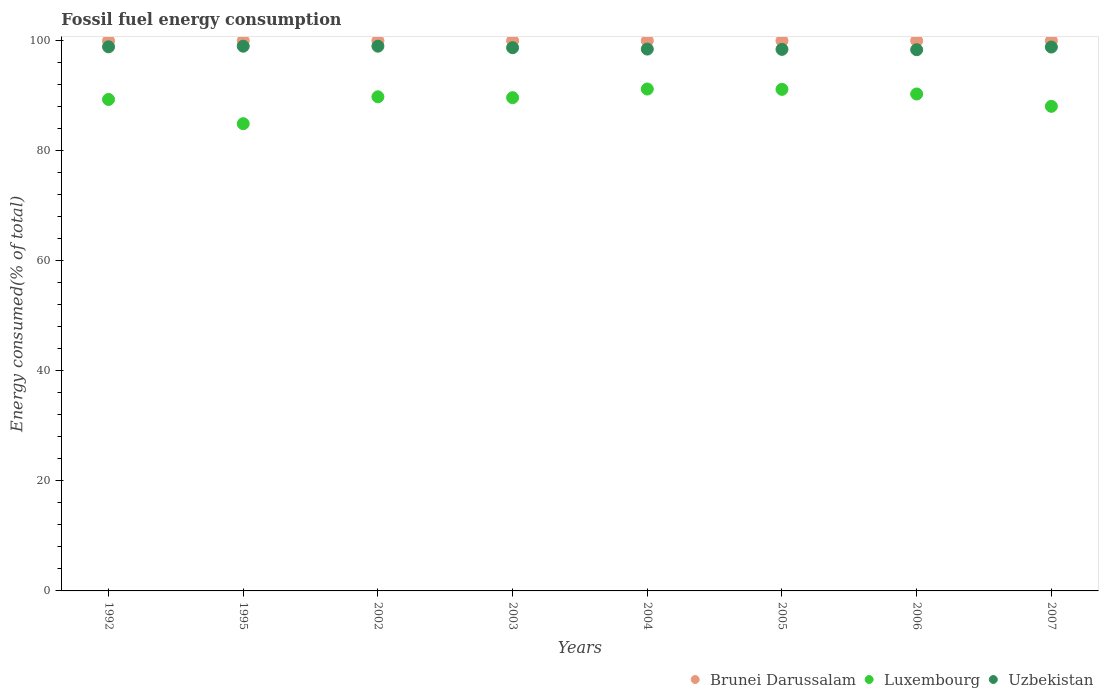What is the percentage of energy consumed in Uzbekistan in 2005?
Offer a very short reply. 98.43. Across all years, what is the maximum percentage of energy consumed in Brunei Darussalam?
Your answer should be very brief. 100. Across all years, what is the minimum percentage of energy consumed in Brunei Darussalam?
Your response must be concise. 99.96. In which year was the percentage of energy consumed in Luxembourg maximum?
Make the answer very short. 2004. In which year was the percentage of energy consumed in Brunei Darussalam minimum?
Provide a short and direct response. 1992. What is the total percentage of energy consumed in Luxembourg in the graph?
Make the answer very short. 714.48. What is the difference between the percentage of energy consumed in Luxembourg in 2005 and that in 2006?
Offer a very short reply. 0.84. What is the difference between the percentage of energy consumed in Brunei Darussalam in 2006 and the percentage of energy consumed in Luxembourg in 2002?
Offer a very short reply. 10.19. What is the average percentage of energy consumed in Brunei Darussalam per year?
Your answer should be very brief. 100. In the year 1995, what is the difference between the percentage of energy consumed in Uzbekistan and percentage of energy consumed in Brunei Darussalam?
Make the answer very short. -1. Is the difference between the percentage of energy consumed in Uzbekistan in 2005 and 2007 greater than the difference between the percentage of energy consumed in Brunei Darussalam in 2005 and 2007?
Offer a very short reply. No. What is the difference between the highest and the second highest percentage of energy consumed in Brunei Darussalam?
Your answer should be very brief. 0. What is the difference between the highest and the lowest percentage of energy consumed in Uzbekistan?
Your answer should be compact. 0.64. Is the sum of the percentage of energy consumed in Brunei Darussalam in 1992 and 2006 greater than the maximum percentage of energy consumed in Luxembourg across all years?
Your answer should be very brief. Yes. Does the percentage of energy consumed in Brunei Darussalam monotonically increase over the years?
Your response must be concise. No. Is the percentage of energy consumed in Brunei Darussalam strictly less than the percentage of energy consumed in Uzbekistan over the years?
Offer a very short reply. No. What is the difference between two consecutive major ticks on the Y-axis?
Your response must be concise. 20. Are the values on the major ticks of Y-axis written in scientific E-notation?
Ensure brevity in your answer.  No. Does the graph contain any zero values?
Provide a short and direct response. No. Where does the legend appear in the graph?
Offer a terse response. Bottom right. What is the title of the graph?
Offer a terse response. Fossil fuel energy consumption. What is the label or title of the Y-axis?
Keep it short and to the point. Energy consumed(% of total). What is the Energy consumed(% of total) of Brunei Darussalam in 1992?
Give a very brief answer. 99.96. What is the Energy consumed(% of total) in Luxembourg in 1992?
Your answer should be very brief. 89.33. What is the Energy consumed(% of total) of Uzbekistan in 1992?
Offer a very short reply. 98.89. What is the Energy consumed(% of total) of Brunei Darussalam in 1995?
Offer a terse response. 100. What is the Energy consumed(% of total) of Luxembourg in 1995?
Ensure brevity in your answer.  84.92. What is the Energy consumed(% of total) of Uzbekistan in 1995?
Provide a short and direct response. 99. What is the Energy consumed(% of total) in Brunei Darussalam in 2002?
Make the answer very short. 100. What is the Energy consumed(% of total) in Luxembourg in 2002?
Make the answer very short. 89.81. What is the Energy consumed(% of total) in Uzbekistan in 2002?
Your response must be concise. 99.01. What is the Energy consumed(% of total) of Brunei Darussalam in 2003?
Your response must be concise. 100. What is the Energy consumed(% of total) in Luxembourg in 2003?
Provide a short and direct response. 89.65. What is the Energy consumed(% of total) of Uzbekistan in 2003?
Ensure brevity in your answer.  98.73. What is the Energy consumed(% of total) of Brunei Darussalam in 2004?
Your answer should be very brief. 100. What is the Energy consumed(% of total) of Luxembourg in 2004?
Provide a short and direct response. 91.22. What is the Energy consumed(% of total) in Uzbekistan in 2004?
Provide a short and direct response. 98.48. What is the Energy consumed(% of total) in Brunei Darussalam in 2005?
Keep it short and to the point. 100. What is the Energy consumed(% of total) in Luxembourg in 2005?
Make the answer very short. 91.16. What is the Energy consumed(% of total) of Uzbekistan in 2005?
Offer a very short reply. 98.43. What is the Energy consumed(% of total) in Luxembourg in 2006?
Keep it short and to the point. 90.32. What is the Energy consumed(% of total) of Uzbekistan in 2006?
Ensure brevity in your answer.  98.37. What is the Energy consumed(% of total) in Brunei Darussalam in 2007?
Provide a short and direct response. 100. What is the Energy consumed(% of total) in Luxembourg in 2007?
Provide a succinct answer. 88.07. What is the Energy consumed(% of total) of Uzbekistan in 2007?
Give a very brief answer. 98.85. Across all years, what is the maximum Energy consumed(% of total) in Luxembourg?
Your answer should be compact. 91.22. Across all years, what is the maximum Energy consumed(% of total) of Uzbekistan?
Your response must be concise. 99.01. Across all years, what is the minimum Energy consumed(% of total) in Brunei Darussalam?
Your answer should be very brief. 99.96. Across all years, what is the minimum Energy consumed(% of total) of Luxembourg?
Keep it short and to the point. 84.92. Across all years, what is the minimum Energy consumed(% of total) in Uzbekistan?
Your answer should be compact. 98.37. What is the total Energy consumed(% of total) of Brunei Darussalam in the graph?
Provide a succinct answer. 799.96. What is the total Energy consumed(% of total) of Luxembourg in the graph?
Offer a very short reply. 714.48. What is the total Energy consumed(% of total) of Uzbekistan in the graph?
Your response must be concise. 789.76. What is the difference between the Energy consumed(% of total) in Brunei Darussalam in 1992 and that in 1995?
Provide a short and direct response. -0.04. What is the difference between the Energy consumed(% of total) in Luxembourg in 1992 and that in 1995?
Provide a succinct answer. 4.41. What is the difference between the Energy consumed(% of total) of Uzbekistan in 1992 and that in 1995?
Provide a succinct answer. -0.11. What is the difference between the Energy consumed(% of total) of Brunei Darussalam in 1992 and that in 2002?
Give a very brief answer. -0.04. What is the difference between the Energy consumed(% of total) in Luxembourg in 1992 and that in 2002?
Provide a short and direct response. -0.48. What is the difference between the Energy consumed(% of total) of Uzbekistan in 1992 and that in 2002?
Give a very brief answer. -0.11. What is the difference between the Energy consumed(% of total) in Brunei Darussalam in 1992 and that in 2003?
Give a very brief answer. -0.04. What is the difference between the Energy consumed(% of total) in Luxembourg in 1992 and that in 2003?
Provide a succinct answer. -0.33. What is the difference between the Energy consumed(% of total) of Uzbekistan in 1992 and that in 2003?
Offer a very short reply. 0.16. What is the difference between the Energy consumed(% of total) of Brunei Darussalam in 1992 and that in 2004?
Your answer should be compact. -0.04. What is the difference between the Energy consumed(% of total) of Luxembourg in 1992 and that in 2004?
Offer a terse response. -1.89. What is the difference between the Energy consumed(% of total) of Uzbekistan in 1992 and that in 2004?
Provide a succinct answer. 0.41. What is the difference between the Energy consumed(% of total) of Brunei Darussalam in 1992 and that in 2005?
Keep it short and to the point. -0.04. What is the difference between the Energy consumed(% of total) in Luxembourg in 1992 and that in 2005?
Make the answer very short. -1.83. What is the difference between the Energy consumed(% of total) of Uzbekistan in 1992 and that in 2005?
Give a very brief answer. 0.46. What is the difference between the Energy consumed(% of total) in Brunei Darussalam in 1992 and that in 2006?
Offer a very short reply. -0.04. What is the difference between the Energy consumed(% of total) of Luxembourg in 1992 and that in 2006?
Make the answer very short. -0.99. What is the difference between the Energy consumed(% of total) of Uzbekistan in 1992 and that in 2006?
Your answer should be compact. 0.53. What is the difference between the Energy consumed(% of total) of Brunei Darussalam in 1992 and that in 2007?
Your answer should be very brief. -0.04. What is the difference between the Energy consumed(% of total) of Luxembourg in 1992 and that in 2007?
Provide a succinct answer. 1.25. What is the difference between the Energy consumed(% of total) in Uzbekistan in 1992 and that in 2007?
Offer a terse response. 0.04. What is the difference between the Energy consumed(% of total) in Luxembourg in 1995 and that in 2002?
Provide a short and direct response. -4.89. What is the difference between the Energy consumed(% of total) in Uzbekistan in 1995 and that in 2002?
Make the answer very short. -0. What is the difference between the Energy consumed(% of total) of Luxembourg in 1995 and that in 2003?
Give a very brief answer. -4.73. What is the difference between the Energy consumed(% of total) of Uzbekistan in 1995 and that in 2003?
Your response must be concise. 0.27. What is the difference between the Energy consumed(% of total) of Brunei Darussalam in 1995 and that in 2004?
Give a very brief answer. 0. What is the difference between the Energy consumed(% of total) in Luxembourg in 1995 and that in 2004?
Your response must be concise. -6.3. What is the difference between the Energy consumed(% of total) of Uzbekistan in 1995 and that in 2004?
Ensure brevity in your answer.  0.52. What is the difference between the Energy consumed(% of total) in Brunei Darussalam in 1995 and that in 2005?
Provide a succinct answer. 0. What is the difference between the Energy consumed(% of total) in Luxembourg in 1995 and that in 2005?
Keep it short and to the point. -6.24. What is the difference between the Energy consumed(% of total) of Uzbekistan in 1995 and that in 2005?
Make the answer very short. 0.58. What is the difference between the Energy consumed(% of total) of Brunei Darussalam in 1995 and that in 2006?
Offer a terse response. 0. What is the difference between the Energy consumed(% of total) of Luxembourg in 1995 and that in 2006?
Offer a terse response. -5.4. What is the difference between the Energy consumed(% of total) in Uzbekistan in 1995 and that in 2006?
Ensure brevity in your answer.  0.64. What is the difference between the Energy consumed(% of total) in Luxembourg in 1995 and that in 2007?
Your answer should be compact. -3.15. What is the difference between the Energy consumed(% of total) of Uzbekistan in 1995 and that in 2007?
Give a very brief answer. 0.15. What is the difference between the Energy consumed(% of total) in Brunei Darussalam in 2002 and that in 2003?
Ensure brevity in your answer.  -0. What is the difference between the Energy consumed(% of total) in Luxembourg in 2002 and that in 2003?
Offer a terse response. 0.15. What is the difference between the Energy consumed(% of total) of Uzbekistan in 2002 and that in 2003?
Your response must be concise. 0.27. What is the difference between the Energy consumed(% of total) of Brunei Darussalam in 2002 and that in 2004?
Offer a very short reply. -0. What is the difference between the Energy consumed(% of total) in Luxembourg in 2002 and that in 2004?
Your answer should be very brief. -1.41. What is the difference between the Energy consumed(% of total) in Uzbekistan in 2002 and that in 2004?
Make the answer very short. 0.53. What is the difference between the Energy consumed(% of total) in Brunei Darussalam in 2002 and that in 2005?
Your answer should be compact. -0. What is the difference between the Energy consumed(% of total) in Luxembourg in 2002 and that in 2005?
Offer a terse response. -1.35. What is the difference between the Energy consumed(% of total) in Uzbekistan in 2002 and that in 2005?
Your response must be concise. 0.58. What is the difference between the Energy consumed(% of total) in Brunei Darussalam in 2002 and that in 2006?
Your response must be concise. -0. What is the difference between the Energy consumed(% of total) in Luxembourg in 2002 and that in 2006?
Your response must be concise. -0.51. What is the difference between the Energy consumed(% of total) in Uzbekistan in 2002 and that in 2006?
Give a very brief answer. 0.64. What is the difference between the Energy consumed(% of total) in Brunei Darussalam in 2002 and that in 2007?
Your response must be concise. -0. What is the difference between the Energy consumed(% of total) in Luxembourg in 2002 and that in 2007?
Your response must be concise. 1.73. What is the difference between the Energy consumed(% of total) of Uzbekistan in 2002 and that in 2007?
Keep it short and to the point. 0.15. What is the difference between the Energy consumed(% of total) of Brunei Darussalam in 2003 and that in 2004?
Offer a terse response. 0. What is the difference between the Energy consumed(% of total) in Luxembourg in 2003 and that in 2004?
Your answer should be very brief. -1.57. What is the difference between the Energy consumed(% of total) of Uzbekistan in 2003 and that in 2004?
Your response must be concise. 0.25. What is the difference between the Energy consumed(% of total) in Luxembourg in 2003 and that in 2005?
Keep it short and to the point. -1.51. What is the difference between the Energy consumed(% of total) of Uzbekistan in 2003 and that in 2005?
Ensure brevity in your answer.  0.31. What is the difference between the Energy consumed(% of total) of Luxembourg in 2003 and that in 2006?
Your answer should be very brief. -0.67. What is the difference between the Energy consumed(% of total) in Uzbekistan in 2003 and that in 2006?
Offer a terse response. 0.37. What is the difference between the Energy consumed(% of total) of Brunei Darussalam in 2003 and that in 2007?
Keep it short and to the point. 0. What is the difference between the Energy consumed(% of total) in Luxembourg in 2003 and that in 2007?
Ensure brevity in your answer.  1.58. What is the difference between the Energy consumed(% of total) in Uzbekistan in 2003 and that in 2007?
Give a very brief answer. -0.12. What is the difference between the Energy consumed(% of total) in Luxembourg in 2004 and that in 2005?
Your answer should be very brief. 0.06. What is the difference between the Energy consumed(% of total) of Uzbekistan in 2004 and that in 2005?
Give a very brief answer. 0.05. What is the difference between the Energy consumed(% of total) of Brunei Darussalam in 2004 and that in 2006?
Provide a succinct answer. 0. What is the difference between the Energy consumed(% of total) of Luxembourg in 2004 and that in 2006?
Offer a terse response. 0.9. What is the difference between the Energy consumed(% of total) in Uzbekistan in 2004 and that in 2006?
Provide a succinct answer. 0.11. What is the difference between the Energy consumed(% of total) of Luxembourg in 2004 and that in 2007?
Provide a short and direct response. 3.15. What is the difference between the Energy consumed(% of total) of Uzbekistan in 2004 and that in 2007?
Give a very brief answer. -0.37. What is the difference between the Energy consumed(% of total) of Luxembourg in 2005 and that in 2006?
Offer a terse response. 0.84. What is the difference between the Energy consumed(% of total) of Uzbekistan in 2005 and that in 2006?
Keep it short and to the point. 0.06. What is the difference between the Energy consumed(% of total) of Luxembourg in 2005 and that in 2007?
Your response must be concise. 3.09. What is the difference between the Energy consumed(% of total) in Uzbekistan in 2005 and that in 2007?
Your answer should be compact. -0.42. What is the difference between the Energy consumed(% of total) of Luxembourg in 2006 and that in 2007?
Your answer should be very brief. 2.25. What is the difference between the Energy consumed(% of total) in Uzbekistan in 2006 and that in 2007?
Your answer should be very brief. -0.49. What is the difference between the Energy consumed(% of total) in Brunei Darussalam in 1992 and the Energy consumed(% of total) in Luxembourg in 1995?
Give a very brief answer. 15.04. What is the difference between the Energy consumed(% of total) of Brunei Darussalam in 1992 and the Energy consumed(% of total) of Uzbekistan in 1995?
Offer a very short reply. 0.96. What is the difference between the Energy consumed(% of total) of Luxembourg in 1992 and the Energy consumed(% of total) of Uzbekistan in 1995?
Ensure brevity in your answer.  -9.68. What is the difference between the Energy consumed(% of total) in Brunei Darussalam in 1992 and the Energy consumed(% of total) in Luxembourg in 2002?
Provide a succinct answer. 10.15. What is the difference between the Energy consumed(% of total) in Brunei Darussalam in 1992 and the Energy consumed(% of total) in Uzbekistan in 2002?
Make the answer very short. 0.96. What is the difference between the Energy consumed(% of total) in Luxembourg in 1992 and the Energy consumed(% of total) in Uzbekistan in 2002?
Make the answer very short. -9.68. What is the difference between the Energy consumed(% of total) in Brunei Darussalam in 1992 and the Energy consumed(% of total) in Luxembourg in 2003?
Provide a succinct answer. 10.31. What is the difference between the Energy consumed(% of total) of Brunei Darussalam in 1992 and the Energy consumed(% of total) of Uzbekistan in 2003?
Offer a terse response. 1.23. What is the difference between the Energy consumed(% of total) in Luxembourg in 1992 and the Energy consumed(% of total) in Uzbekistan in 2003?
Offer a very short reply. -9.41. What is the difference between the Energy consumed(% of total) of Brunei Darussalam in 1992 and the Energy consumed(% of total) of Luxembourg in 2004?
Keep it short and to the point. 8.74. What is the difference between the Energy consumed(% of total) in Brunei Darussalam in 1992 and the Energy consumed(% of total) in Uzbekistan in 2004?
Your answer should be compact. 1.48. What is the difference between the Energy consumed(% of total) of Luxembourg in 1992 and the Energy consumed(% of total) of Uzbekistan in 2004?
Your response must be concise. -9.15. What is the difference between the Energy consumed(% of total) of Brunei Darussalam in 1992 and the Energy consumed(% of total) of Luxembourg in 2005?
Make the answer very short. 8.8. What is the difference between the Energy consumed(% of total) of Brunei Darussalam in 1992 and the Energy consumed(% of total) of Uzbekistan in 2005?
Your answer should be compact. 1.53. What is the difference between the Energy consumed(% of total) in Luxembourg in 1992 and the Energy consumed(% of total) in Uzbekistan in 2005?
Give a very brief answer. -9.1. What is the difference between the Energy consumed(% of total) of Brunei Darussalam in 1992 and the Energy consumed(% of total) of Luxembourg in 2006?
Make the answer very short. 9.64. What is the difference between the Energy consumed(% of total) of Brunei Darussalam in 1992 and the Energy consumed(% of total) of Uzbekistan in 2006?
Offer a terse response. 1.6. What is the difference between the Energy consumed(% of total) in Luxembourg in 1992 and the Energy consumed(% of total) in Uzbekistan in 2006?
Ensure brevity in your answer.  -9.04. What is the difference between the Energy consumed(% of total) in Brunei Darussalam in 1992 and the Energy consumed(% of total) in Luxembourg in 2007?
Your response must be concise. 11.89. What is the difference between the Energy consumed(% of total) in Brunei Darussalam in 1992 and the Energy consumed(% of total) in Uzbekistan in 2007?
Give a very brief answer. 1.11. What is the difference between the Energy consumed(% of total) of Luxembourg in 1992 and the Energy consumed(% of total) of Uzbekistan in 2007?
Provide a short and direct response. -9.52. What is the difference between the Energy consumed(% of total) of Brunei Darussalam in 1995 and the Energy consumed(% of total) of Luxembourg in 2002?
Ensure brevity in your answer.  10.19. What is the difference between the Energy consumed(% of total) of Brunei Darussalam in 1995 and the Energy consumed(% of total) of Uzbekistan in 2002?
Make the answer very short. 0.99. What is the difference between the Energy consumed(% of total) in Luxembourg in 1995 and the Energy consumed(% of total) in Uzbekistan in 2002?
Your answer should be compact. -14.09. What is the difference between the Energy consumed(% of total) of Brunei Darussalam in 1995 and the Energy consumed(% of total) of Luxembourg in 2003?
Provide a short and direct response. 10.35. What is the difference between the Energy consumed(% of total) in Brunei Darussalam in 1995 and the Energy consumed(% of total) in Uzbekistan in 2003?
Provide a short and direct response. 1.27. What is the difference between the Energy consumed(% of total) in Luxembourg in 1995 and the Energy consumed(% of total) in Uzbekistan in 2003?
Your answer should be very brief. -13.81. What is the difference between the Energy consumed(% of total) in Brunei Darussalam in 1995 and the Energy consumed(% of total) in Luxembourg in 2004?
Provide a succinct answer. 8.78. What is the difference between the Energy consumed(% of total) of Brunei Darussalam in 1995 and the Energy consumed(% of total) of Uzbekistan in 2004?
Make the answer very short. 1.52. What is the difference between the Energy consumed(% of total) in Luxembourg in 1995 and the Energy consumed(% of total) in Uzbekistan in 2004?
Provide a short and direct response. -13.56. What is the difference between the Energy consumed(% of total) of Brunei Darussalam in 1995 and the Energy consumed(% of total) of Luxembourg in 2005?
Provide a short and direct response. 8.84. What is the difference between the Energy consumed(% of total) in Brunei Darussalam in 1995 and the Energy consumed(% of total) in Uzbekistan in 2005?
Your response must be concise. 1.57. What is the difference between the Energy consumed(% of total) in Luxembourg in 1995 and the Energy consumed(% of total) in Uzbekistan in 2005?
Ensure brevity in your answer.  -13.51. What is the difference between the Energy consumed(% of total) in Brunei Darussalam in 1995 and the Energy consumed(% of total) in Luxembourg in 2006?
Provide a short and direct response. 9.68. What is the difference between the Energy consumed(% of total) of Brunei Darussalam in 1995 and the Energy consumed(% of total) of Uzbekistan in 2006?
Keep it short and to the point. 1.63. What is the difference between the Energy consumed(% of total) in Luxembourg in 1995 and the Energy consumed(% of total) in Uzbekistan in 2006?
Your answer should be compact. -13.45. What is the difference between the Energy consumed(% of total) in Brunei Darussalam in 1995 and the Energy consumed(% of total) in Luxembourg in 2007?
Offer a very short reply. 11.93. What is the difference between the Energy consumed(% of total) of Brunei Darussalam in 1995 and the Energy consumed(% of total) of Uzbekistan in 2007?
Offer a very short reply. 1.15. What is the difference between the Energy consumed(% of total) of Luxembourg in 1995 and the Energy consumed(% of total) of Uzbekistan in 2007?
Your response must be concise. -13.93. What is the difference between the Energy consumed(% of total) in Brunei Darussalam in 2002 and the Energy consumed(% of total) in Luxembourg in 2003?
Ensure brevity in your answer.  10.35. What is the difference between the Energy consumed(% of total) of Brunei Darussalam in 2002 and the Energy consumed(% of total) of Uzbekistan in 2003?
Your answer should be very brief. 1.27. What is the difference between the Energy consumed(% of total) of Luxembourg in 2002 and the Energy consumed(% of total) of Uzbekistan in 2003?
Your answer should be very brief. -8.93. What is the difference between the Energy consumed(% of total) in Brunei Darussalam in 2002 and the Energy consumed(% of total) in Luxembourg in 2004?
Keep it short and to the point. 8.78. What is the difference between the Energy consumed(% of total) of Brunei Darussalam in 2002 and the Energy consumed(% of total) of Uzbekistan in 2004?
Ensure brevity in your answer.  1.52. What is the difference between the Energy consumed(% of total) in Luxembourg in 2002 and the Energy consumed(% of total) in Uzbekistan in 2004?
Provide a succinct answer. -8.67. What is the difference between the Energy consumed(% of total) in Brunei Darussalam in 2002 and the Energy consumed(% of total) in Luxembourg in 2005?
Provide a short and direct response. 8.84. What is the difference between the Energy consumed(% of total) of Brunei Darussalam in 2002 and the Energy consumed(% of total) of Uzbekistan in 2005?
Offer a very short reply. 1.57. What is the difference between the Energy consumed(% of total) of Luxembourg in 2002 and the Energy consumed(% of total) of Uzbekistan in 2005?
Keep it short and to the point. -8.62. What is the difference between the Energy consumed(% of total) of Brunei Darussalam in 2002 and the Energy consumed(% of total) of Luxembourg in 2006?
Give a very brief answer. 9.68. What is the difference between the Energy consumed(% of total) of Brunei Darussalam in 2002 and the Energy consumed(% of total) of Uzbekistan in 2006?
Give a very brief answer. 1.63. What is the difference between the Energy consumed(% of total) of Luxembourg in 2002 and the Energy consumed(% of total) of Uzbekistan in 2006?
Provide a short and direct response. -8.56. What is the difference between the Energy consumed(% of total) of Brunei Darussalam in 2002 and the Energy consumed(% of total) of Luxembourg in 2007?
Provide a short and direct response. 11.93. What is the difference between the Energy consumed(% of total) of Brunei Darussalam in 2002 and the Energy consumed(% of total) of Uzbekistan in 2007?
Your response must be concise. 1.15. What is the difference between the Energy consumed(% of total) in Luxembourg in 2002 and the Energy consumed(% of total) in Uzbekistan in 2007?
Offer a terse response. -9.04. What is the difference between the Energy consumed(% of total) of Brunei Darussalam in 2003 and the Energy consumed(% of total) of Luxembourg in 2004?
Offer a terse response. 8.78. What is the difference between the Energy consumed(% of total) of Brunei Darussalam in 2003 and the Energy consumed(% of total) of Uzbekistan in 2004?
Your answer should be very brief. 1.52. What is the difference between the Energy consumed(% of total) in Luxembourg in 2003 and the Energy consumed(% of total) in Uzbekistan in 2004?
Your answer should be compact. -8.83. What is the difference between the Energy consumed(% of total) in Brunei Darussalam in 2003 and the Energy consumed(% of total) in Luxembourg in 2005?
Provide a short and direct response. 8.84. What is the difference between the Energy consumed(% of total) in Brunei Darussalam in 2003 and the Energy consumed(% of total) in Uzbekistan in 2005?
Provide a short and direct response. 1.57. What is the difference between the Energy consumed(% of total) in Luxembourg in 2003 and the Energy consumed(% of total) in Uzbekistan in 2005?
Provide a succinct answer. -8.78. What is the difference between the Energy consumed(% of total) of Brunei Darussalam in 2003 and the Energy consumed(% of total) of Luxembourg in 2006?
Give a very brief answer. 9.68. What is the difference between the Energy consumed(% of total) of Brunei Darussalam in 2003 and the Energy consumed(% of total) of Uzbekistan in 2006?
Provide a succinct answer. 1.63. What is the difference between the Energy consumed(% of total) in Luxembourg in 2003 and the Energy consumed(% of total) in Uzbekistan in 2006?
Your answer should be compact. -8.71. What is the difference between the Energy consumed(% of total) of Brunei Darussalam in 2003 and the Energy consumed(% of total) of Luxembourg in 2007?
Offer a very short reply. 11.93. What is the difference between the Energy consumed(% of total) of Brunei Darussalam in 2003 and the Energy consumed(% of total) of Uzbekistan in 2007?
Offer a terse response. 1.15. What is the difference between the Energy consumed(% of total) of Luxembourg in 2003 and the Energy consumed(% of total) of Uzbekistan in 2007?
Your answer should be very brief. -9.2. What is the difference between the Energy consumed(% of total) in Brunei Darussalam in 2004 and the Energy consumed(% of total) in Luxembourg in 2005?
Make the answer very short. 8.84. What is the difference between the Energy consumed(% of total) in Brunei Darussalam in 2004 and the Energy consumed(% of total) in Uzbekistan in 2005?
Give a very brief answer. 1.57. What is the difference between the Energy consumed(% of total) in Luxembourg in 2004 and the Energy consumed(% of total) in Uzbekistan in 2005?
Keep it short and to the point. -7.21. What is the difference between the Energy consumed(% of total) in Brunei Darussalam in 2004 and the Energy consumed(% of total) in Luxembourg in 2006?
Offer a terse response. 9.68. What is the difference between the Energy consumed(% of total) of Brunei Darussalam in 2004 and the Energy consumed(% of total) of Uzbekistan in 2006?
Keep it short and to the point. 1.63. What is the difference between the Energy consumed(% of total) in Luxembourg in 2004 and the Energy consumed(% of total) in Uzbekistan in 2006?
Provide a short and direct response. -7.14. What is the difference between the Energy consumed(% of total) of Brunei Darussalam in 2004 and the Energy consumed(% of total) of Luxembourg in 2007?
Keep it short and to the point. 11.93. What is the difference between the Energy consumed(% of total) in Brunei Darussalam in 2004 and the Energy consumed(% of total) in Uzbekistan in 2007?
Offer a very short reply. 1.15. What is the difference between the Energy consumed(% of total) of Luxembourg in 2004 and the Energy consumed(% of total) of Uzbekistan in 2007?
Your response must be concise. -7.63. What is the difference between the Energy consumed(% of total) in Brunei Darussalam in 2005 and the Energy consumed(% of total) in Luxembourg in 2006?
Your response must be concise. 9.68. What is the difference between the Energy consumed(% of total) of Brunei Darussalam in 2005 and the Energy consumed(% of total) of Uzbekistan in 2006?
Keep it short and to the point. 1.63. What is the difference between the Energy consumed(% of total) of Luxembourg in 2005 and the Energy consumed(% of total) of Uzbekistan in 2006?
Ensure brevity in your answer.  -7.21. What is the difference between the Energy consumed(% of total) in Brunei Darussalam in 2005 and the Energy consumed(% of total) in Luxembourg in 2007?
Offer a very short reply. 11.93. What is the difference between the Energy consumed(% of total) in Brunei Darussalam in 2005 and the Energy consumed(% of total) in Uzbekistan in 2007?
Offer a terse response. 1.15. What is the difference between the Energy consumed(% of total) of Luxembourg in 2005 and the Energy consumed(% of total) of Uzbekistan in 2007?
Provide a short and direct response. -7.69. What is the difference between the Energy consumed(% of total) of Brunei Darussalam in 2006 and the Energy consumed(% of total) of Luxembourg in 2007?
Offer a terse response. 11.93. What is the difference between the Energy consumed(% of total) of Brunei Darussalam in 2006 and the Energy consumed(% of total) of Uzbekistan in 2007?
Your response must be concise. 1.15. What is the difference between the Energy consumed(% of total) in Luxembourg in 2006 and the Energy consumed(% of total) in Uzbekistan in 2007?
Your answer should be very brief. -8.53. What is the average Energy consumed(% of total) of Brunei Darussalam per year?
Your answer should be compact. 100. What is the average Energy consumed(% of total) of Luxembourg per year?
Provide a short and direct response. 89.31. What is the average Energy consumed(% of total) of Uzbekistan per year?
Offer a very short reply. 98.72. In the year 1992, what is the difference between the Energy consumed(% of total) of Brunei Darussalam and Energy consumed(% of total) of Luxembourg?
Provide a succinct answer. 10.63. In the year 1992, what is the difference between the Energy consumed(% of total) of Brunei Darussalam and Energy consumed(% of total) of Uzbekistan?
Your response must be concise. 1.07. In the year 1992, what is the difference between the Energy consumed(% of total) in Luxembourg and Energy consumed(% of total) in Uzbekistan?
Ensure brevity in your answer.  -9.56. In the year 1995, what is the difference between the Energy consumed(% of total) in Brunei Darussalam and Energy consumed(% of total) in Luxembourg?
Your answer should be compact. 15.08. In the year 1995, what is the difference between the Energy consumed(% of total) in Brunei Darussalam and Energy consumed(% of total) in Uzbekistan?
Offer a very short reply. 1. In the year 1995, what is the difference between the Energy consumed(% of total) in Luxembourg and Energy consumed(% of total) in Uzbekistan?
Offer a very short reply. -14.08. In the year 2002, what is the difference between the Energy consumed(% of total) of Brunei Darussalam and Energy consumed(% of total) of Luxembourg?
Provide a succinct answer. 10.19. In the year 2002, what is the difference between the Energy consumed(% of total) in Brunei Darussalam and Energy consumed(% of total) in Uzbekistan?
Offer a very short reply. 0.99. In the year 2002, what is the difference between the Energy consumed(% of total) in Luxembourg and Energy consumed(% of total) in Uzbekistan?
Provide a succinct answer. -9.2. In the year 2003, what is the difference between the Energy consumed(% of total) of Brunei Darussalam and Energy consumed(% of total) of Luxembourg?
Your answer should be compact. 10.35. In the year 2003, what is the difference between the Energy consumed(% of total) of Brunei Darussalam and Energy consumed(% of total) of Uzbekistan?
Make the answer very short. 1.27. In the year 2003, what is the difference between the Energy consumed(% of total) of Luxembourg and Energy consumed(% of total) of Uzbekistan?
Give a very brief answer. -9.08. In the year 2004, what is the difference between the Energy consumed(% of total) of Brunei Darussalam and Energy consumed(% of total) of Luxembourg?
Provide a short and direct response. 8.78. In the year 2004, what is the difference between the Energy consumed(% of total) of Brunei Darussalam and Energy consumed(% of total) of Uzbekistan?
Offer a very short reply. 1.52. In the year 2004, what is the difference between the Energy consumed(% of total) in Luxembourg and Energy consumed(% of total) in Uzbekistan?
Your answer should be very brief. -7.26. In the year 2005, what is the difference between the Energy consumed(% of total) of Brunei Darussalam and Energy consumed(% of total) of Luxembourg?
Offer a terse response. 8.84. In the year 2005, what is the difference between the Energy consumed(% of total) in Brunei Darussalam and Energy consumed(% of total) in Uzbekistan?
Provide a short and direct response. 1.57. In the year 2005, what is the difference between the Energy consumed(% of total) in Luxembourg and Energy consumed(% of total) in Uzbekistan?
Keep it short and to the point. -7.27. In the year 2006, what is the difference between the Energy consumed(% of total) in Brunei Darussalam and Energy consumed(% of total) in Luxembourg?
Give a very brief answer. 9.68. In the year 2006, what is the difference between the Energy consumed(% of total) of Brunei Darussalam and Energy consumed(% of total) of Uzbekistan?
Keep it short and to the point. 1.63. In the year 2006, what is the difference between the Energy consumed(% of total) in Luxembourg and Energy consumed(% of total) in Uzbekistan?
Offer a terse response. -8.05. In the year 2007, what is the difference between the Energy consumed(% of total) of Brunei Darussalam and Energy consumed(% of total) of Luxembourg?
Your answer should be very brief. 11.93. In the year 2007, what is the difference between the Energy consumed(% of total) in Brunei Darussalam and Energy consumed(% of total) in Uzbekistan?
Offer a terse response. 1.15. In the year 2007, what is the difference between the Energy consumed(% of total) in Luxembourg and Energy consumed(% of total) in Uzbekistan?
Provide a succinct answer. -10.78. What is the ratio of the Energy consumed(% of total) in Luxembourg in 1992 to that in 1995?
Offer a terse response. 1.05. What is the ratio of the Energy consumed(% of total) of Uzbekistan in 1992 to that in 1995?
Your answer should be very brief. 1. What is the ratio of the Energy consumed(% of total) of Brunei Darussalam in 1992 to that in 2002?
Offer a very short reply. 1. What is the ratio of the Energy consumed(% of total) of Uzbekistan in 1992 to that in 2002?
Offer a terse response. 1. What is the ratio of the Energy consumed(% of total) in Brunei Darussalam in 1992 to that in 2003?
Provide a succinct answer. 1. What is the ratio of the Energy consumed(% of total) in Luxembourg in 1992 to that in 2003?
Ensure brevity in your answer.  1. What is the ratio of the Energy consumed(% of total) in Uzbekistan in 1992 to that in 2003?
Offer a terse response. 1. What is the ratio of the Energy consumed(% of total) in Brunei Darussalam in 1992 to that in 2004?
Keep it short and to the point. 1. What is the ratio of the Energy consumed(% of total) in Luxembourg in 1992 to that in 2004?
Ensure brevity in your answer.  0.98. What is the ratio of the Energy consumed(% of total) of Uzbekistan in 1992 to that in 2004?
Give a very brief answer. 1. What is the ratio of the Energy consumed(% of total) of Brunei Darussalam in 1992 to that in 2005?
Keep it short and to the point. 1. What is the ratio of the Energy consumed(% of total) in Luxembourg in 1992 to that in 2005?
Keep it short and to the point. 0.98. What is the ratio of the Energy consumed(% of total) of Uzbekistan in 1992 to that in 2005?
Make the answer very short. 1. What is the ratio of the Energy consumed(% of total) of Uzbekistan in 1992 to that in 2006?
Offer a terse response. 1.01. What is the ratio of the Energy consumed(% of total) in Brunei Darussalam in 1992 to that in 2007?
Offer a terse response. 1. What is the ratio of the Energy consumed(% of total) in Luxembourg in 1992 to that in 2007?
Your answer should be very brief. 1.01. What is the ratio of the Energy consumed(% of total) in Luxembourg in 1995 to that in 2002?
Your answer should be compact. 0.95. What is the ratio of the Energy consumed(% of total) in Uzbekistan in 1995 to that in 2002?
Your response must be concise. 1. What is the ratio of the Energy consumed(% of total) of Brunei Darussalam in 1995 to that in 2003?
Make the answer very short. 1. What is the ratio of the Energy consumed(% of total) of Luxembourg in 1995 to that in 2003?
Offer a terse response. 0.95. What is the ratio of the Energy consumed(% of total) of Luxembourg in 1995 to that in 2004?
Ensure brevity in your answer.  0.93. What is the ratio of the Energy consumed(% of total) in Uzbekistan in 1995 to that in 2004?
Your answer should be very brief. 1.01. What is the ratio of the Energy consumed(% of total) of Luxembourg in 1995 to that in 2005?
Keep it short and to the point. 0.93. What is the ratio of the Energy consumed(% of total) of Uzbekistan in 1995 to that in 2005?
Provide a short and direct response. 1.01. What is the ratio of the Energy consumed(% of total) in Brunei Darussalam in 1995 to that in 2006?
Your answer should be compact. 1. What is the ratio of the Energy consumed(% of total) of Luxembourg in 1995 to that in 2006?
Keep it short and to the point. 0.94. What is the ratio of the Energy consumed(% of total) of Luxembourg in 1995 to that in 2007?
Your answer should be very brief. 0.96. What is the ratio of the Energy consumed(% of total) in Luxembourg in 2002 to that in 2004?
Offer a very short reply. 0.98. What is the ratio of the Energy consumed(% of total) of Uzbekistan in 2002 to that in 2004?
Ensure brevity in your answer.  1.01. What is the ratio of the Energy consumed(% of total) in Luxembourg in 2002 to that in 2005?
Offer a very short reply. 0.99. What is the ratio of the Energy consumed(% of total) of Uzbekistan in 2002 to that in 2005?
Give a very brief answer. 1.01. What is the ratio of the Energy consumed(% of total) of Luxembourg in 2002 to that in 2007?
Offer a very short reply. 1.02. What is the ratio of the Energy consumed(% of total) in Luxembourg in 2003 to that in 2004?
Your answer should be compact. 0.98. What is the ratio of the Energy consumed(% of total) in Uzbekistan in 2003 to that in 2004?
Provide a short and direct response. 1. What is the ratio of the Energy consumed(% of total) in Brunei Darussalam in 2003 to that in 2005?
Make the answer very short. 1. What is the ratio of the Energy consumed(% of total) in Luxembourg in 2003 to that in 2005?
Ensure brevity in your answer.  0.98. What is the ratio of the Energy consumed(% of total) in Uzbekistan in 2003 to that in 2005?
Your answer should be compact. 1. What is the ratio of the Energy consumed(% of total) of Brunei Darussalam in 2003 to that in 2006?
Your answer should be compact. 1. What is the ratio of the Energy consumed(% of total) in Luxembourg in 2003 to that in 2006?
Provide a succinct answer. 0.99. What is the ratio of the Energy consumed(% of total) of Brunei Darussalam in 2003 to that in 2007?
Offer a very short reply. 1. What is the ratio of the Energy consumed(% of total) of Luxembourg in 2003 to that in 2007?
Provide a short and direct response. 1.02. What is the ratio of the Energy consumed(% of total) of Uzbekistan in 2004 to that in 2005?
Give a very brief answer. 1. What is the ratio of the Energy consumed(% of total) in Luxembourg in 2004 to that in 2006?
Provide a short and direct response. 1.01. What is the ratio of the Energy consumed(% of total) in Luxembourg in 2004 to that in 2007?
Provide a short and direct response. 1.04. What is the ratio of the Energy consumed(% of total) in Brunei Darussalam in 2005 to that in 2006?
Offer a very short reply. 1. What is the ratio of the Energy consumed(% of total) of Luxembourg in 2005 to that in 2006?
Keep it short and to the point. 1.01. What is the ratio of the Energy consumed(% of total) of Uzbekistan in 2005 to that in 2006?
Ensure brevity in your answer.  1. What is the ratio of the Energy consumed(% of total) of Brunei Darussalam in 2005 to that in 2007?
Offer a terse response. 1. What is the ratio of the Energy consumed(% of total) of Luxembourg in 2005 to that in 2007?
Give a very brief answer. 1.03. What is the ratio of the Energy consumed(% of total) of Uzbekistan in 2005 to that in 2007?
Provide a succinct answer. 1. What is the ratio of the Energy consumed(% of total) in Luxembourg in 2006 to that in 2007?
Give a very brief answer. 1.03. What is the difference between the highest and the second highest Energy consumed(% of total) in Luxembourg?
Your answer should be very brief. 0.06. What is the difference between the highest and the second highest Energy consumed(% of total) of Uzbekistan?
Offer a terse response. 0. What is the difference between the highest and the lowest Energy consumed(% of total) in Brunei Darussalam?
Make the answer very short. 0.04. What is the difference between the highest and the lowest Energy consumed(% of total) in Luxembourg?
Keep it short and to the point. 6.3. What is the difference between the highest and the lowest Energy consumed(% of total) in Uzbekistan?
Make the answer very short. 0.64. 